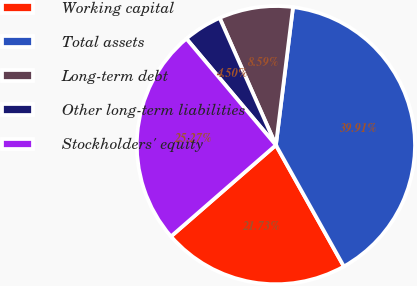<chart> <loc_0><loc_0><loc_500><loc_500><pie_chart><fcel>Working capital<fcel>Total assets<fcel>Long-term debt<fcel>Other long-term liabilities<fcel>Stockholders' equity<nl><fcel>21.73%<fcel>39.91%<fcel>8.59%<fcel>4.5%<fcel>25.27%<nl></chart> 